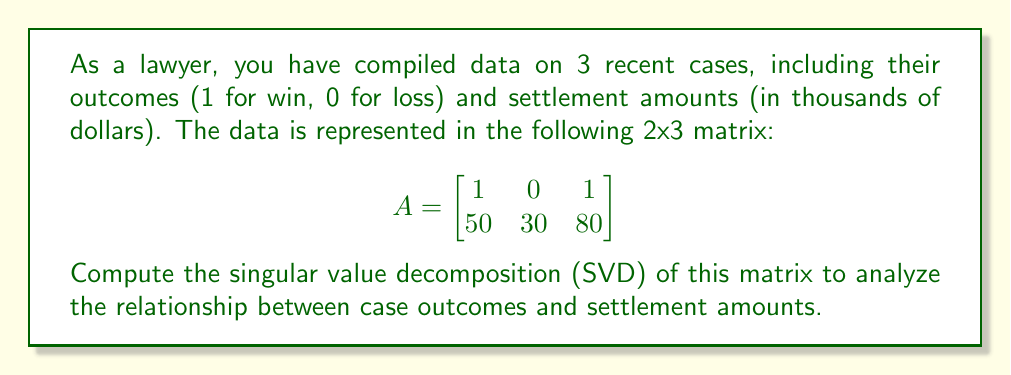Can you solve this math problem? To compute the Singular Value Decomposition (SVD) of matrix A, we need to find matrices U, Σ, and V such that A = UΣV^T. Here's a step-by-step process:

1) First, calculate A^T A and AA^T:

   $$A^T A = \begin{bmatrix}
   1 & 50 \\
   0 & 30 \\
   1 & 80
   \end{bmatrix} \begin{bmatrix}
   1 & 0 & 1 \\
   50 & 30 & 80
   \end{bmatrix} = \begin{bmatrix}
   2501 & 1500 & 4001 \\
   1500 & 900 & 2400 \\
   4001 & 2400 & 6401
   \end{bmatrix}$$

   $$AA^T = \begin{bmatrix}
   1 & 0 & 1 \\
   50 & 30 & 80
   \end{bmatrix} \begin{bmatrix}
   1 & 50 \\
   0 & 30 \\
   1 & 80
   \end{bmatrix} = \begin{bmatrix}
   2 & 130 \\
   130 & 9800
   \end{bmatrix}$$

2) Find the eigenvalues of A^T A (which are the squares of the singular values):
   Characteristic equation: $\det(A^T A - \lambda I) = 0$
   This yields: $\lambda_1 \approx 9802.92$ and $\lambda_2 \approx 0.08$
   
   The singular values are the square roots of these:
   $\sigma_1 \approx 99.01$ and $\sigma_2 \approx 0.28$

3) Find the right singular vectors (columns of V) by solving $(A^T A - \lambda_i I)v_i = 0$:
   
   $$V \approx \begin{bmatrix}
   0.2525 & -0.9676 \\
   0.1515 & 0.2525 \\
   0.4040 & 0.0101
   \end{bmatrix}$$

4) Find the left singular vectors (columns of U) by calculating $Av_i / \sigma_i$:

   $$U \approx \begin{bmatrix}
   0.0152 & -0.9999 \\
   0.9999 & 0.0152
   \end{bmatrix}$$

5) Construct the diagonal matrix Σ with the singular values:

   $$\Sigma = \begin{bmatrix}
   99.01 & 0 & 0 \\
   0 & 0.28 & 0
   \end{bmatrix}$$

Therefore, the SVD of A is:

$$A = U\Sigma V^T \approx \begin{bmatrix}
0.0152 & -0.9999 \\
0.9999 & 0.0152
\end{bmatrix} \begin{bmatrix}
99.01 & 0 & 0 \\
0 & 0.28 & 0
\end{bmatrix} \begin{bmatrix}
0.2525 & 0.1515 & 0.4040 \\
-0.9676 & 0.2525 & 0.0101
\end{bmatrix}$$
Answer: $$A \approx \begin{bmatrix}
0.0152 & -0.9999 \\
0.9999 & 0.0152
\end{bmatrix} \begin{bmatrix}
99.01 & 0 & 0 \\
0 & 0.28 & 0
\end{bmatrix} \begin{bmatrix}
0.2525 & 0.1515 & 0.4040 \\
-0.9676 & 0.2525 & 0.0101
\end{bmatrix}$$ 